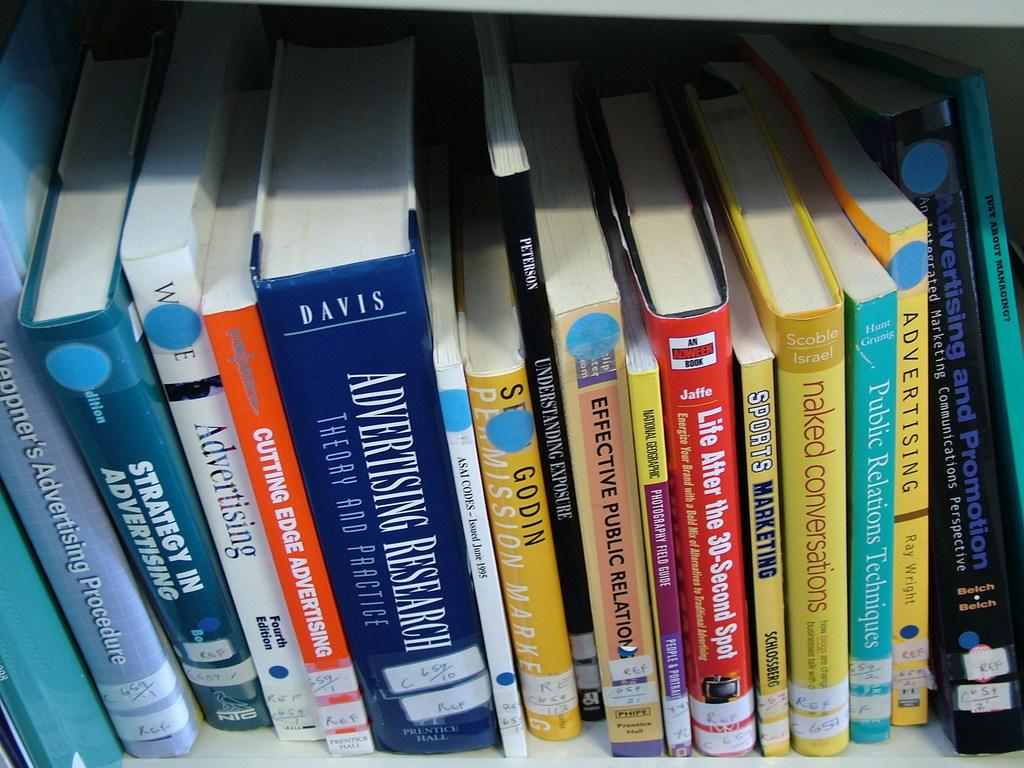Provide a one-sentence caption for the provided image. A shelf full of books some of which are about advertising. 